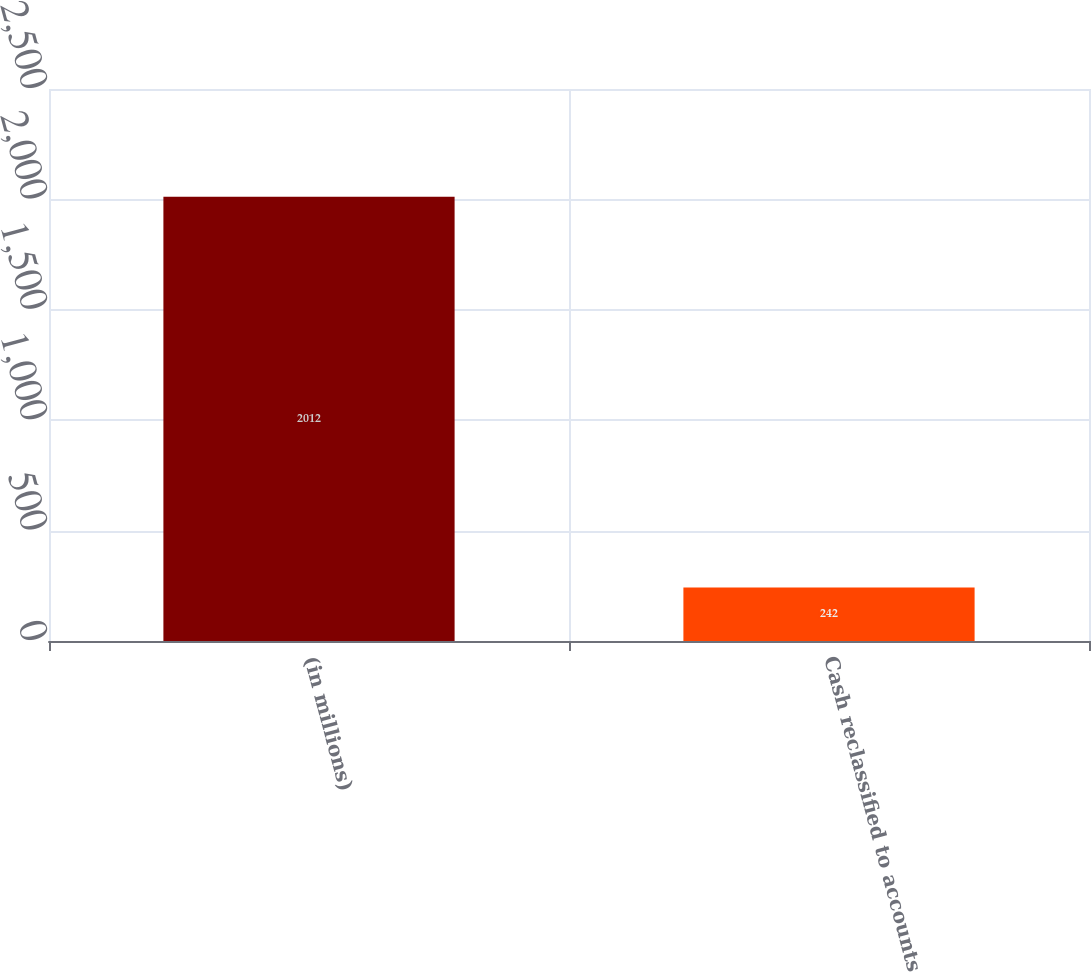Convert chart to OTSL. <chart><loc_0><loc_0><loc_500><loc_500><bar_chart><fcel>(in millions)<fcel>Cash reclassified to accounts<nl><fcel>2012<fcel>242<nl></chart> 